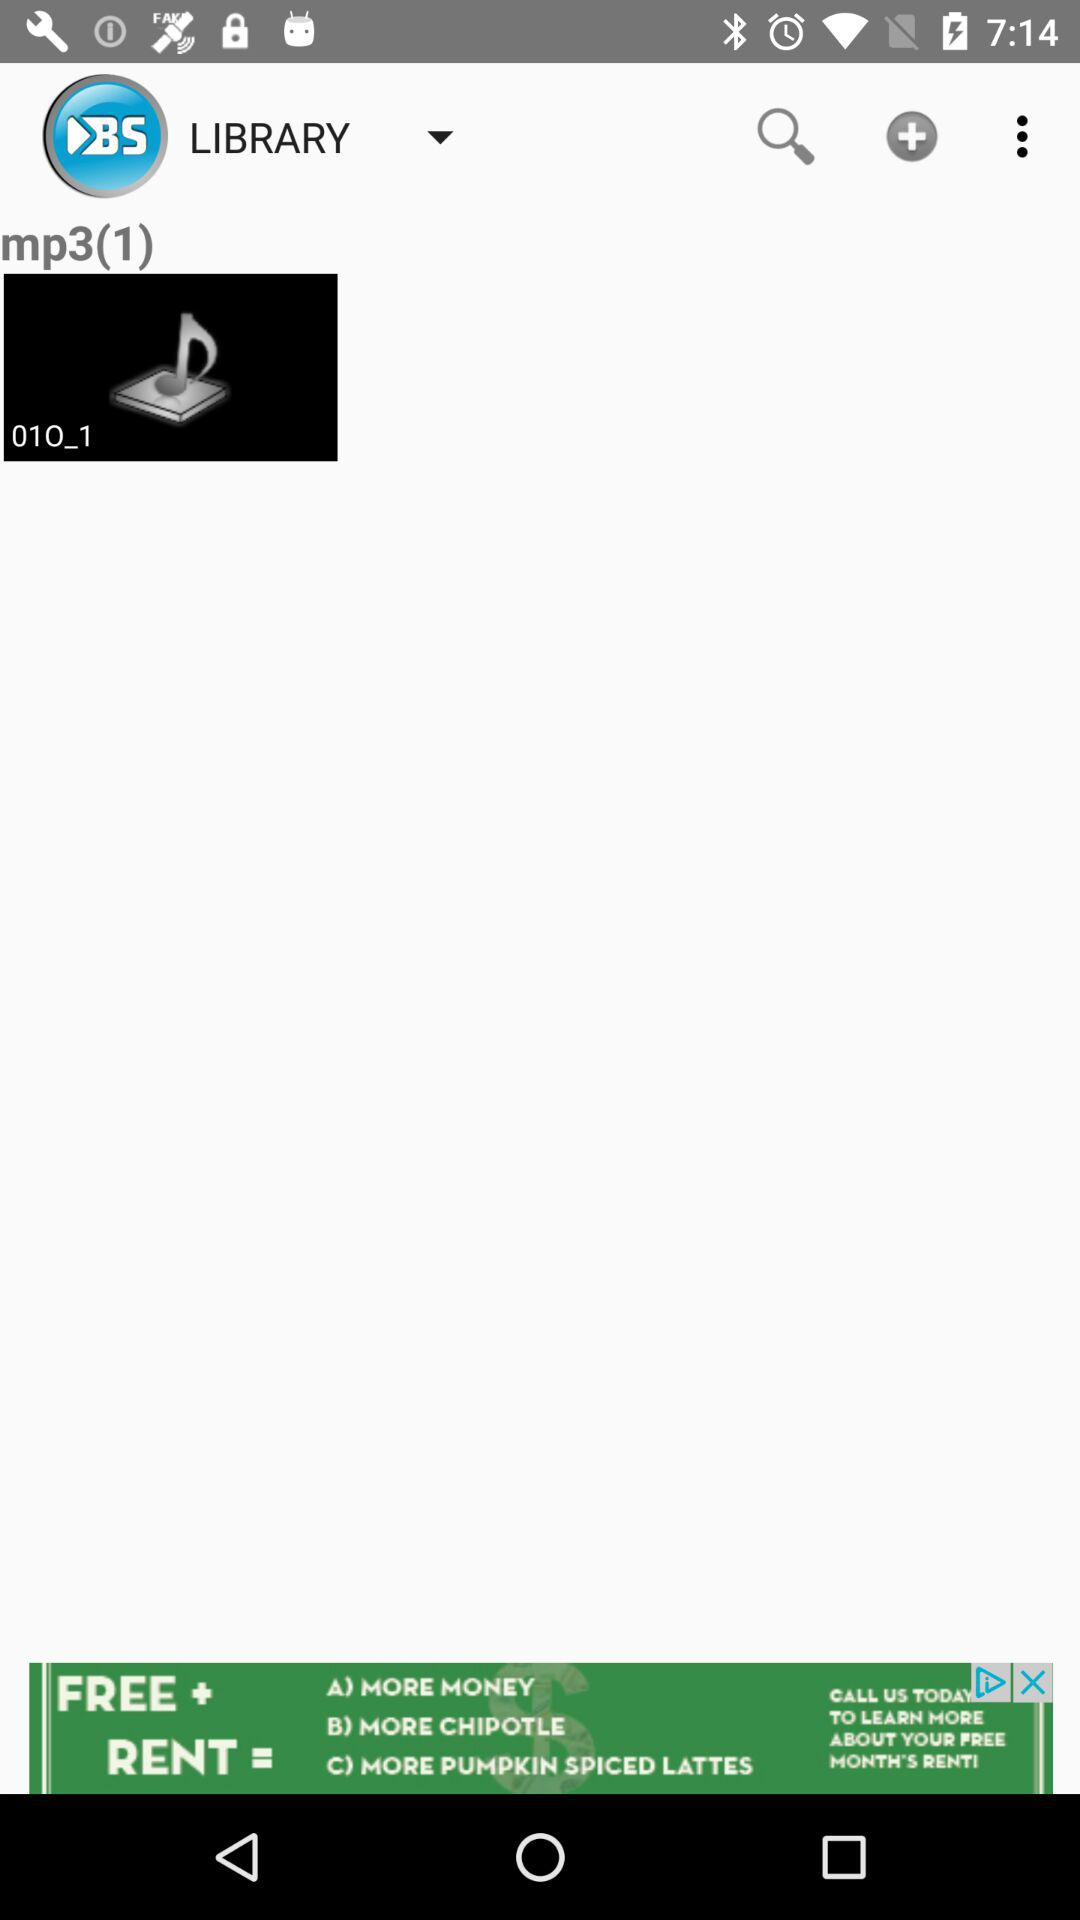How many songs are there in the "LIBRARY"? There is 1 song in the "LIBRARY". 